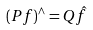<formula> <loc_0><loc_0><loc_500><loc_500>( P f ) ^ { \wedge } = Q \hat { f }</formula> 